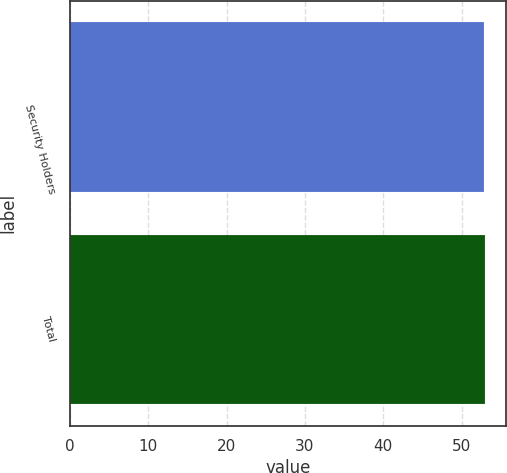<chart> <loc_0><loc_0><loc_500><loc_500><bar_chart><fcel>Security Holders<fcel>Total<nl><fcel>52.87<fcel>52.97<nl></chart> 